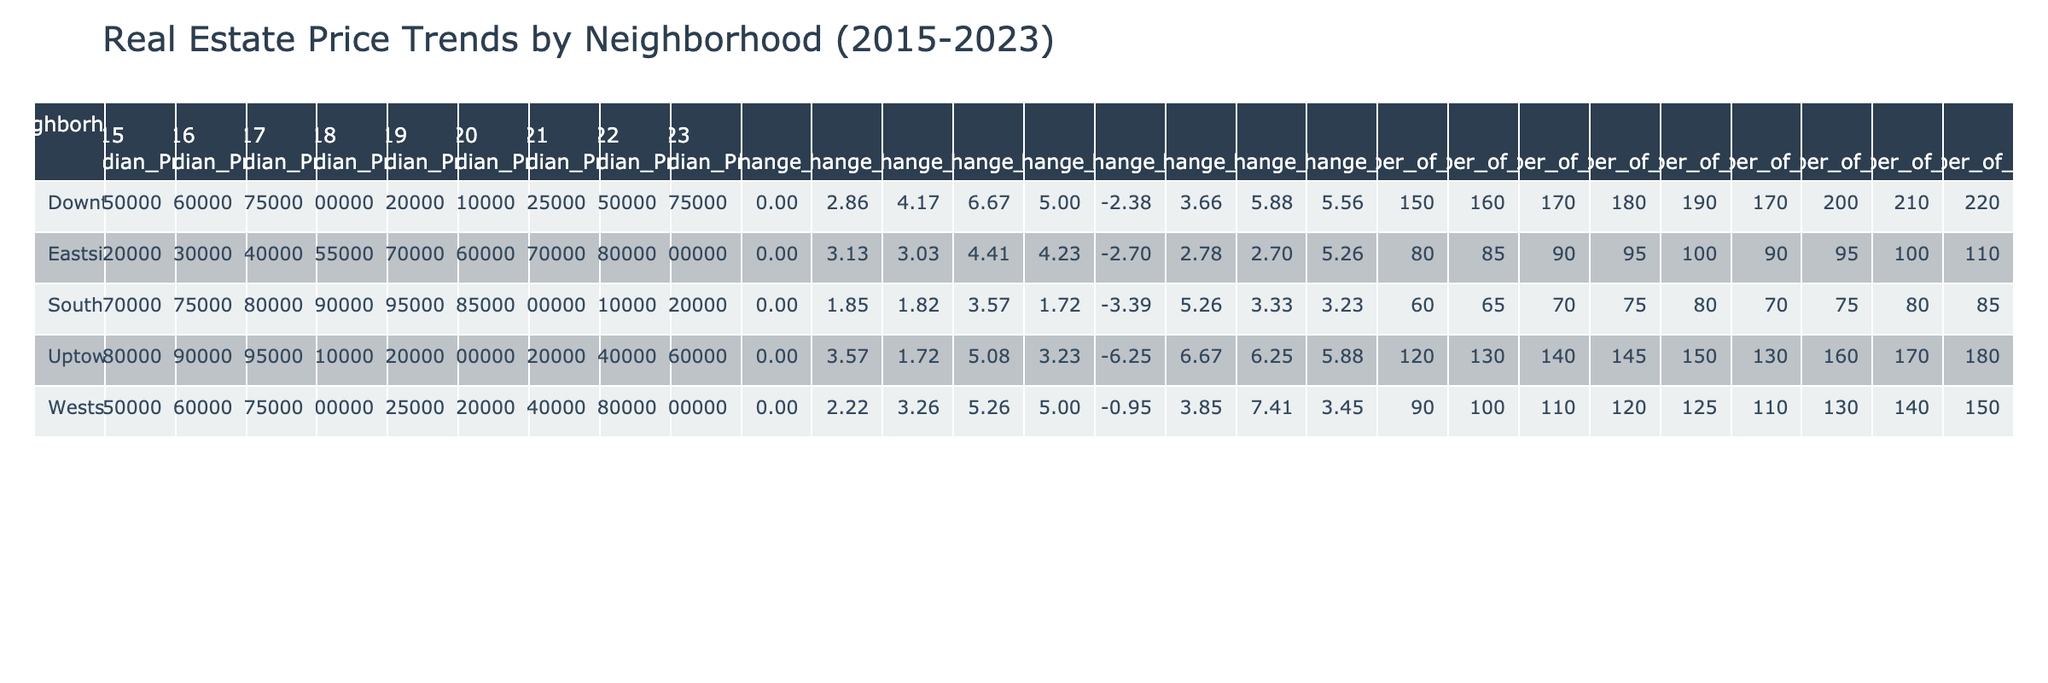What was the median price in Downtown in 2021? From the table, the row for Downtown shows that in 2021 the median price is listed directly as 425000.
Answer: 425000 Which neighborhood showed the highest median price in 2023? The table lists the median prices for each neighborhood in 2023: Downtown (475000), Uptown (360000), Westside (600000), Eastside (400000), and Southside (320000). Among these, Westside has the highest price at 600000.
Answer: Westside What was the price change percentage for Eastside from 2020 to 2021? For Eastside, the price in 2020 was 360000 and in 2021 it was 370000. The percentage change can be calculated as ((370000 - 360000) / 360000) * 100, which equals approximately 2.78%.
Answer: 2.78% Did Uptown experience a price decrease in 2020? In the table, the entry for Uptown in 2020 shows a median price of 300000, with a price change percentage of -6.25%, indicating a decrease.
Answer: Yes What is the total number of sales in Southside from 2015 to 2023? The number of sales recorded for Southside each year is: 60 (2015), 65 (2016), 70 (2017), 75 (2018), 80 (2019), 70 (2020), 75 (2021), 80 (2022), and 85 (2023). Adding these values gives a total of 60 + 65 + 70 + 75 + 80 + 70 + 75 + 80 + 85 = 690.
Answer: 690 What is the average median price for Westside from 2015 to 2023? The median prices for Westside over the years are: 450000 (2015), 460000 (2016), 475000 (2017), 500000 (2018), 525000 (2019), 520000 (2020), 540000 (2021), 580000 (2022), and 600000 (2023). Summing these gives 450000 + 460000 + 475000 + 500000 + 525000 + 520000 + 540000 + 580000 + 600000 = 4550000. There are 9 data points, so the average is 4550000 / 9 = 505555.56.
Answer: 505555.56 